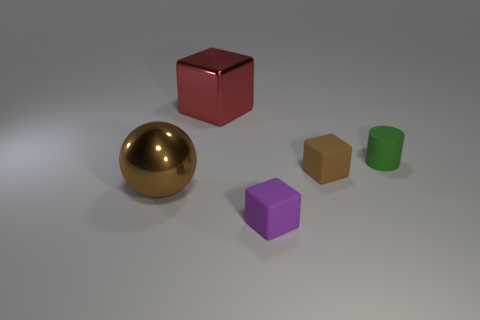Add 2 tiny red shiny spheres. How many objects exist? 7 Subtract all cubes. How many objects are left? 2 Add 3 large red things. How many large red things are left? 4 Add 3 large red metallic blocks. How many large red metallic blocks exist? 4 Subtract 1 red cubes. How many objects are left? 4 Subtract all tiny purple things. Subtract all small rubber objects. How many objects are left? 1 